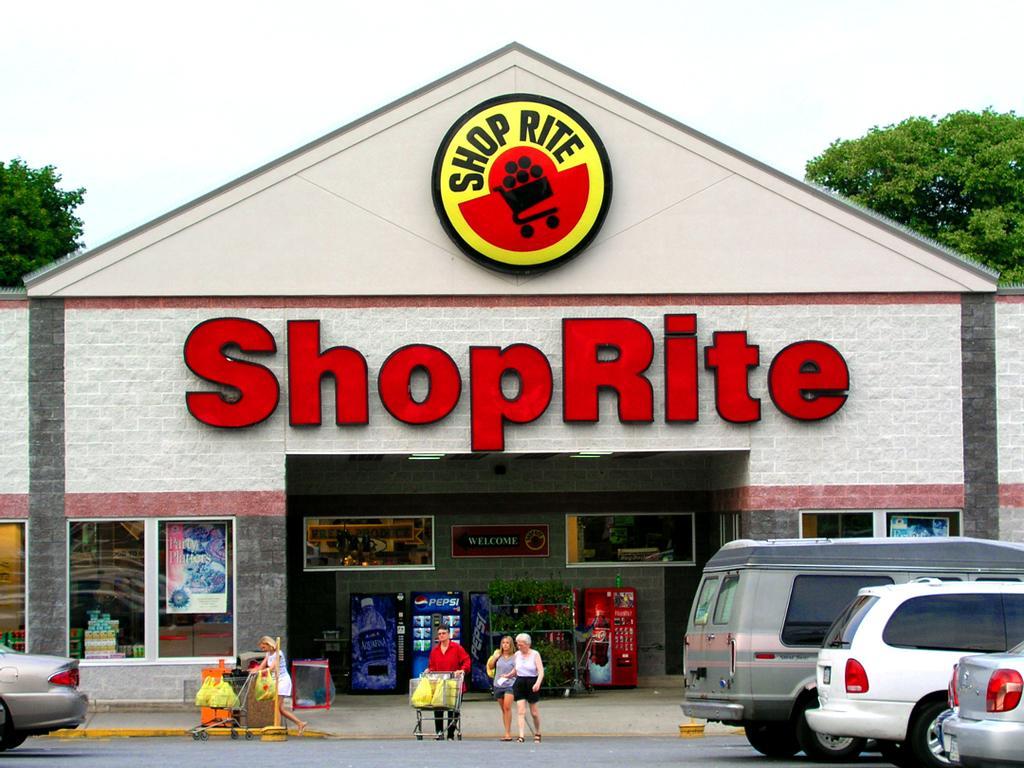Could you give a brief overview of what you see in this image? In this image I can see a building, vehicles on the road and people. I can also see trolleys and some other machines. In the background I can see trees and the sky. On the building I can see a logo and a name which is red in color. 